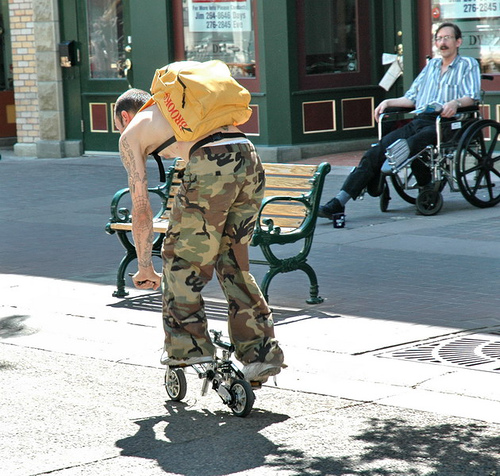Identify the text contained in this image. 276 BROOK 